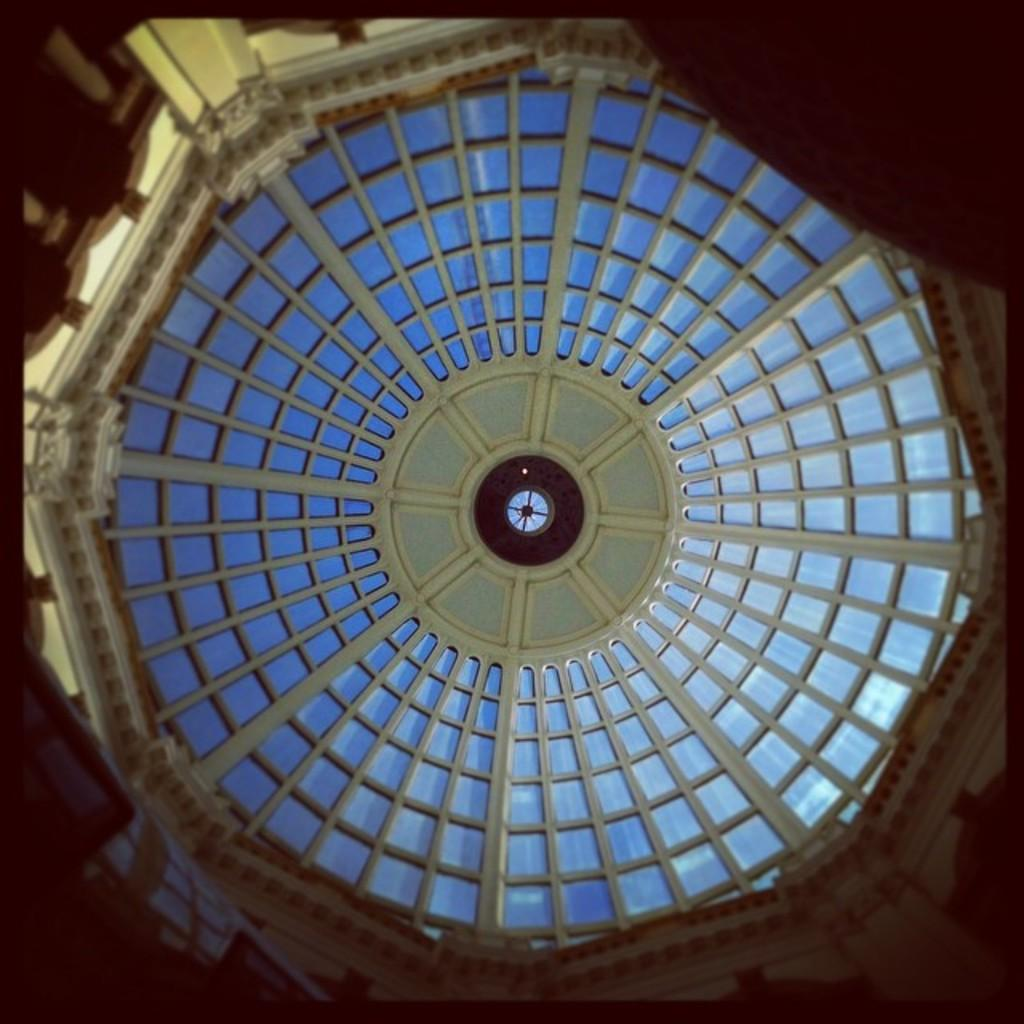What is located above the area shown in the image? There is a ceiling in the image. What feature can be seen on the ceiling? The ceiling has glass windows. What type of architectural element is present in the image? There are pillars in the image. What separates the space shown in the image from other areas? There is a wall in the image. How does the team interact with the light in the image? There is no team present in the image, so it is not possible to answer how they might interact with the light. 